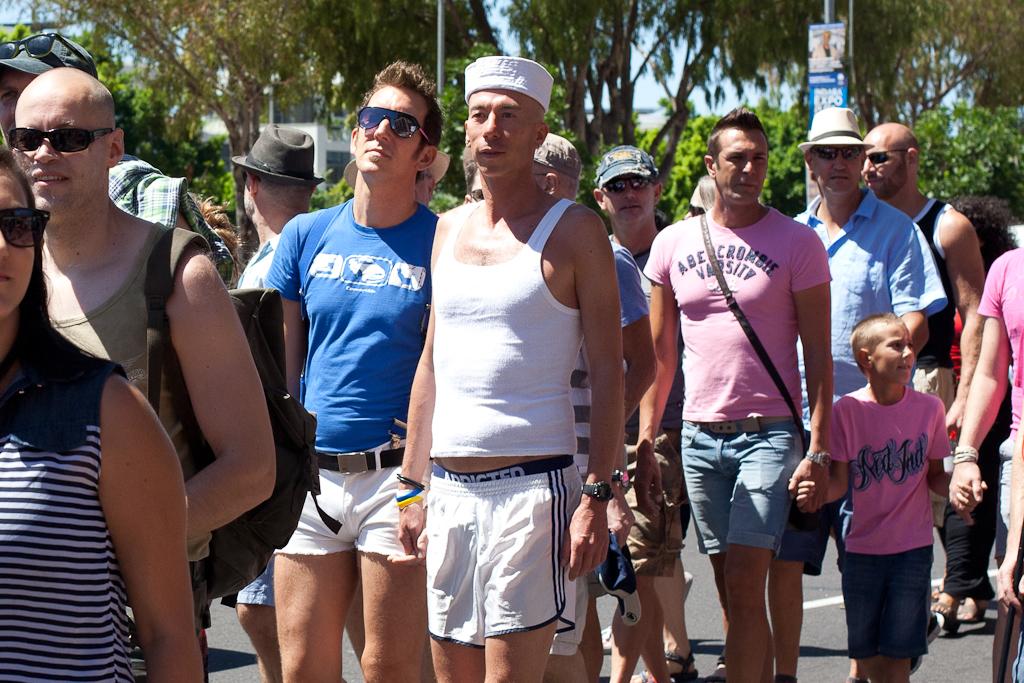What store brand is the pink shirt that the man is wearing?
Your response must be concise. Abercrombie. 